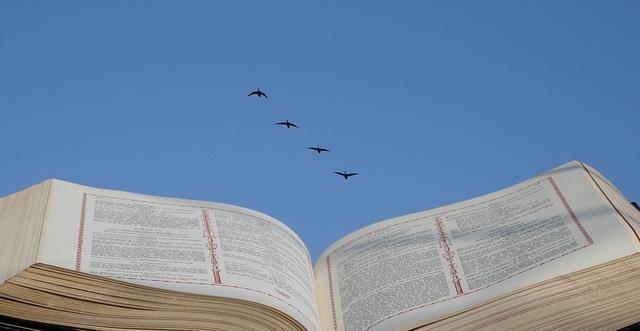How many birds are in the sky?
Give a very brief answer. 4. How many cars can be seen?
Give a very brief answer. 0. 